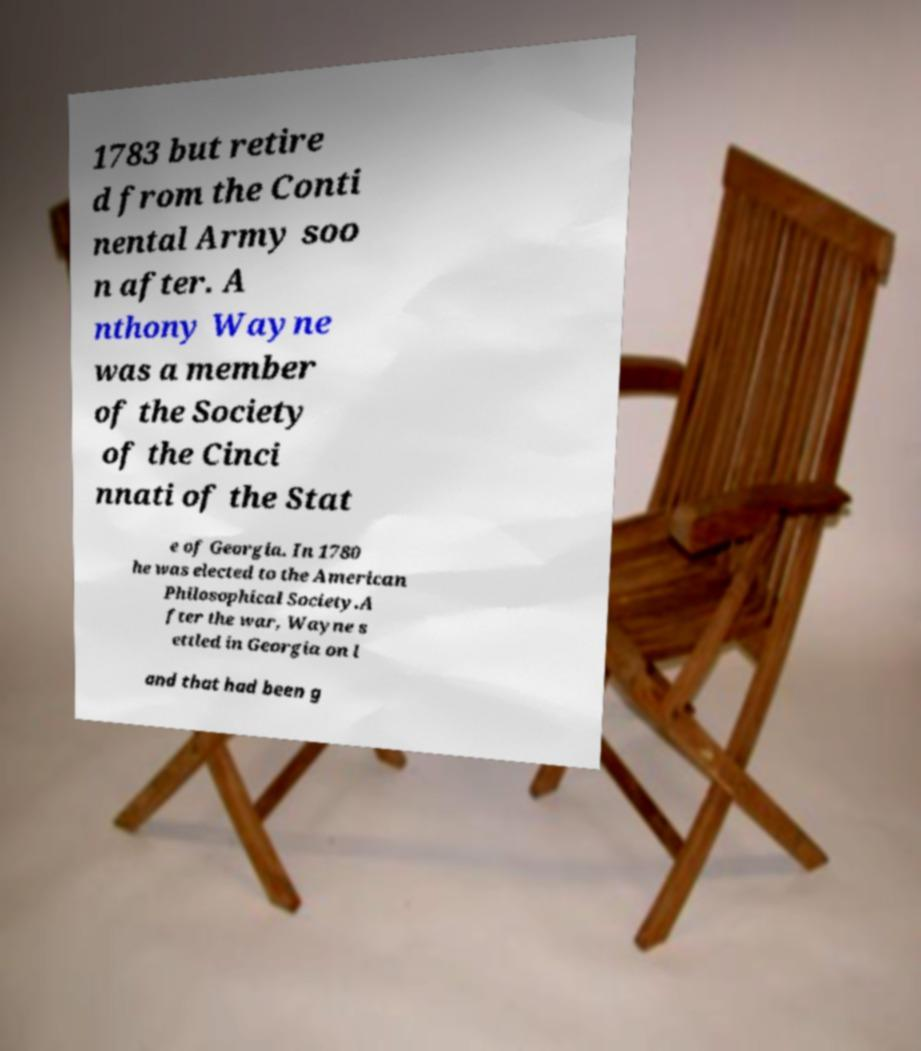I need the written content from this picture converted into text. Can you do that? 1783 but retire d from the Conti nental Army soo n after. A nthony Wayne was a member of the Society of the Cinci nnati of the Stat e of Georgia. In 1780 he was elected to the American Philosophical Society.A fter the war, Wayne s ettled in Georgia on l and that had been g 